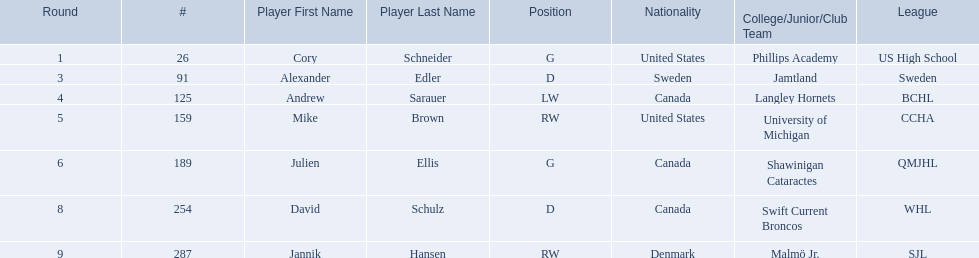Who were the players in the 2004-05 vancouver canucks season Cory Schneider (G), Alexander Edler (D), Andrew Sarauer (LW), Mike Brown (RW), Julien Ellis (G), David Schulz (D), Jannik Hansen (RW). Of these players who had a nationality of denmark? Jannik Hansen (RW). 